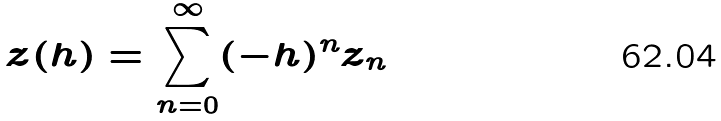<formula> <loc_0><loc_0><loc_500><loc_500>z ( h ) = \sum _ { n = 0 } ^ { \infty } ( - h ) ^ { n } z _ { n }</formula> 